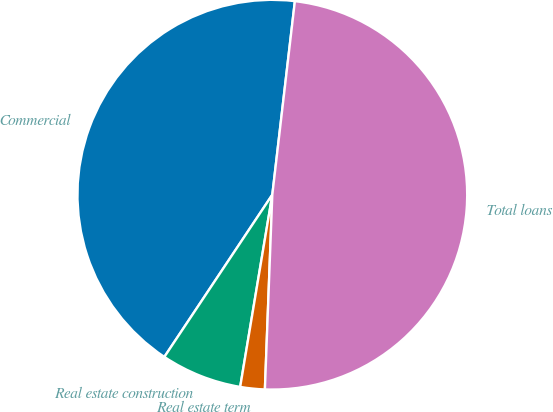Convert chart to OTSL. <chart><loc_0><loc_0><loc_500><loc_500><pie_chart><fcel>Commercial<fcel>Real estate construction<fcel>Real estate term<fcel>Total loans<nl><fcel>42.5%<fcel>6.71%<fcel>2.03%<fcel>48.76%<nl></chart> 